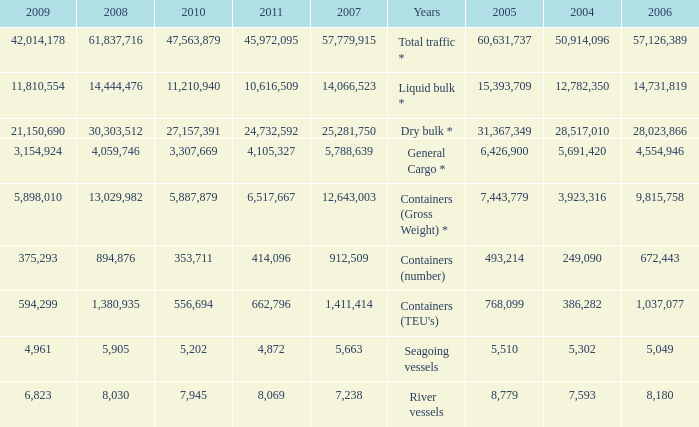What was the average value in 2005 when 2008 is 61,837,716, and a 2006 is more than 57,126,389? None. 